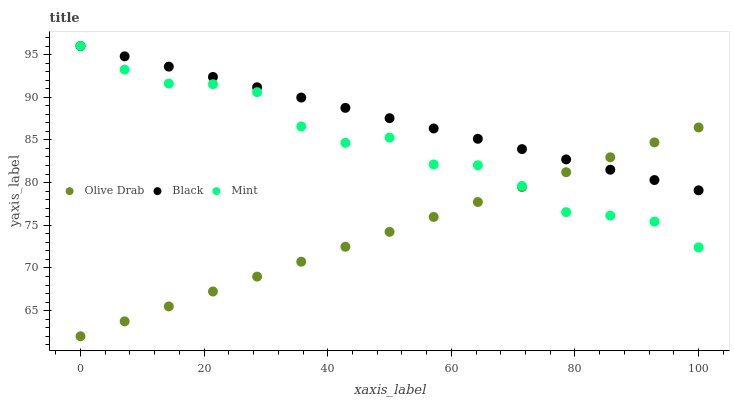Does Olive Drab have the minimum area under the curve?
Answer yes or no. Yes. Does Black have the maximum area under the curve?
Answer yes or no. Yes. Does Black have the minimum area under the curve?
Answer yes or no. No. Does Olive Drab have the maximum area under the curve?
Answer yes or no. No. Is Black the smoothest?
Answer yes or no. Yes. Is Mint the roughest?
Answer yes or no. Yes. Is Olive Drab the smoothest?
Answer yes or no. No. Is Olive Drab the roughest?
Answer yes or no. No. Does Olive Drab have the lowest value?
Answer yes or no. Yes. Does Black have the lowest value?
Answer yes or no. No. Does Black have the highest value?
Answer yes or no. Yes. Does Olive Drab have the highest value?
Answer yes or no. No. Does Olive Drab intersect Mint?
Answer yes or no. Yes. Is Olive Drab less than Mint?
Answer yes or no. No. Is Olive Drab greater than Mint?
Answer yes or no. No. 